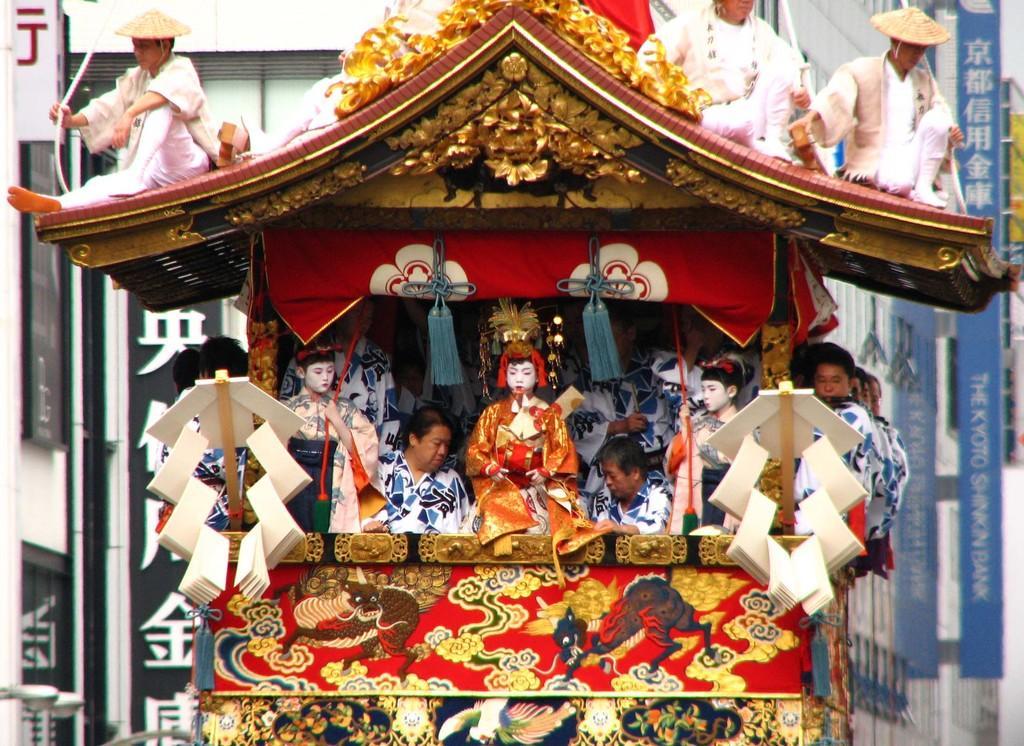Can you describe this image briefly? This picture seems to be clicked outside. In the center we can see an object seems to be a vehicle and we can see the group of persons holding some objects and standing and we can see the group of persons and some objects attached to the vehicle and we can see the group of persons holding some objects and sitting. In the background we can see the text and the buildings and some other objects and we can see the pictures of some objects. 